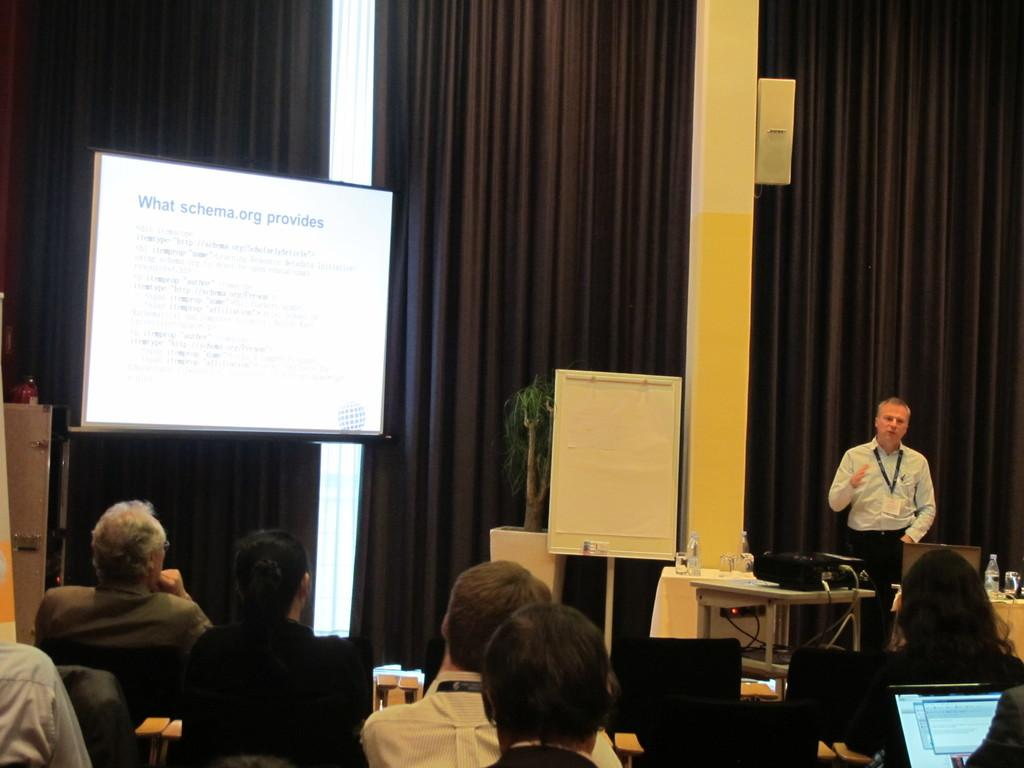How many people are in the image? There is a group of people in the image. What electronic devices can be seen in the image? There are laptops in the image. What type of beverage containers are present in the image? There are bottles in the image. What is the main focus of the group's activity in the image? The presence of a projector screen and a projector suggests that they are engaged in a presentation or watching something together. What type of plant is in the image? There is a houseplant in the image. What type of window treatment is visible in the image? There is a curtain in the background of the image. What type of stocking is being worn by the person in the image? There is no mention of any person wearing stockings in the image. What type of medical equipment can be seen in the image? There is no medical equipment present in the image; it features a group of people, laptops, bottles, a projector screen, a projector, a houseplant, and a curtain. 